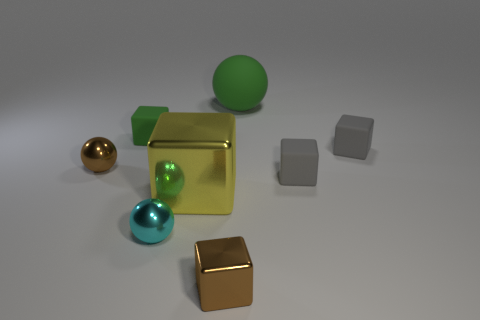Subtract all large metallic blocks. How many blocks are left? 4 Subtract all green cubes. How many cubes are left? 4 Subtract all cyan blocks. Subtract all gray spheres. How many blocks are left? 5 Add 1 big red metallic blocks. How many objects exist? 9 Subtract all spheres. How many objects are left? 5 Subtract 0 yellow spheres. How many objects are left? 8 Subtract all purple things. Subtract all small metal cubes. How many objects are left? 7 Add 6 tiny gray matte things. How many tiny gray matte things are left? 8 Add 6 green things. How many green things exist? 8 